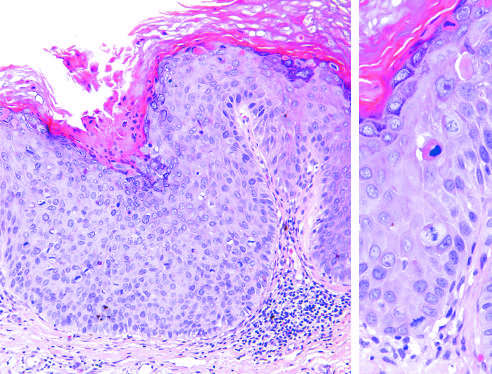what shows delayed maturation and disorganization?
Answer the question using a single word or phrase. The epithelium 